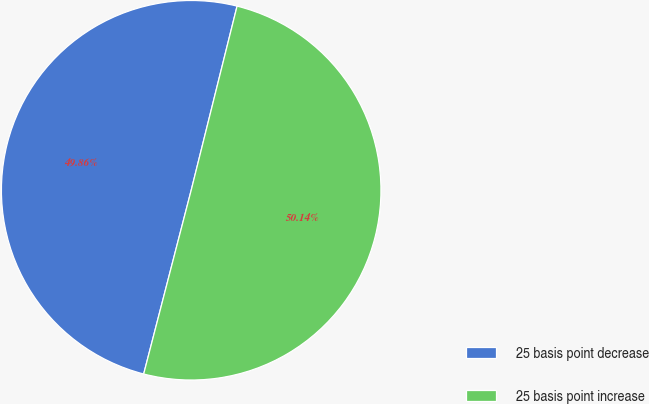<chart> <loc_0><loc_0><loc_500><loc_500><pie_chart><fcel>25 basis point decrease<fcel>25 basis point increase<nl><fcel>49.86%<fcel>50.14%<nl></chart> 